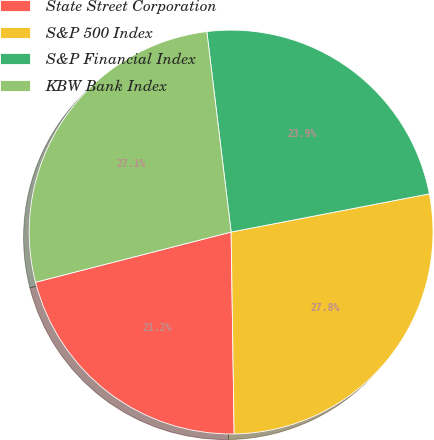Convert chart to OTSL. <chart><loc_0><loc_0><loc_500><loc_500><pie_chart><fcel>State Street Corporation<fcel>S&P 500 Index<fcel>S&P Financial Index<fcel>KBW Bank Index<nl><fcel>21.24%<fcel>27.79%<fcel>23.89%<fcel>27.08%<nl></chart> 